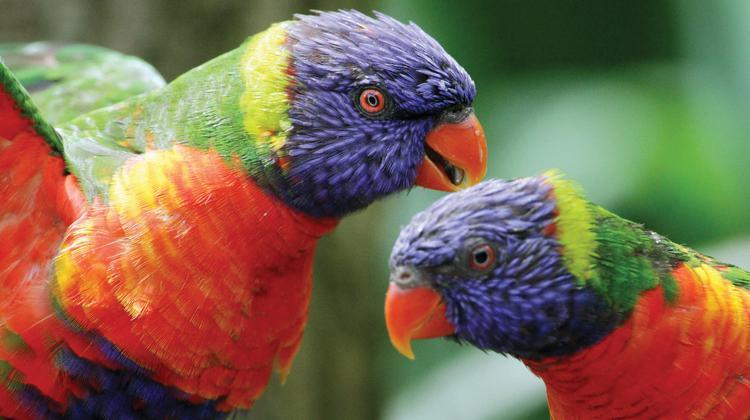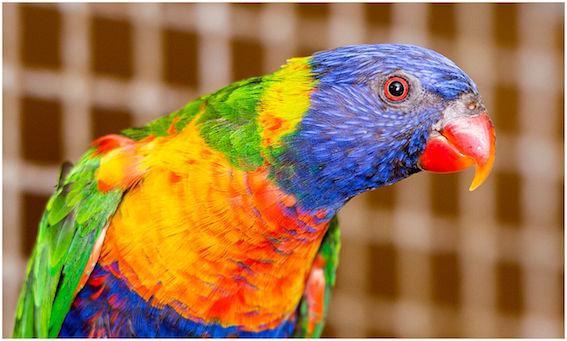The first image is the image on the left, the second image is the image on the right. Evaluate the accuracy of this statement regarding the images: "The left image includes twice as many parrots as the right image.". Is it true? Answer yes or no. Yes. The first image is the image on the left, the second image is the image on the right. For the images shown, is this caption "At least two parrots are facing left." true? Answer yes or no. No. 